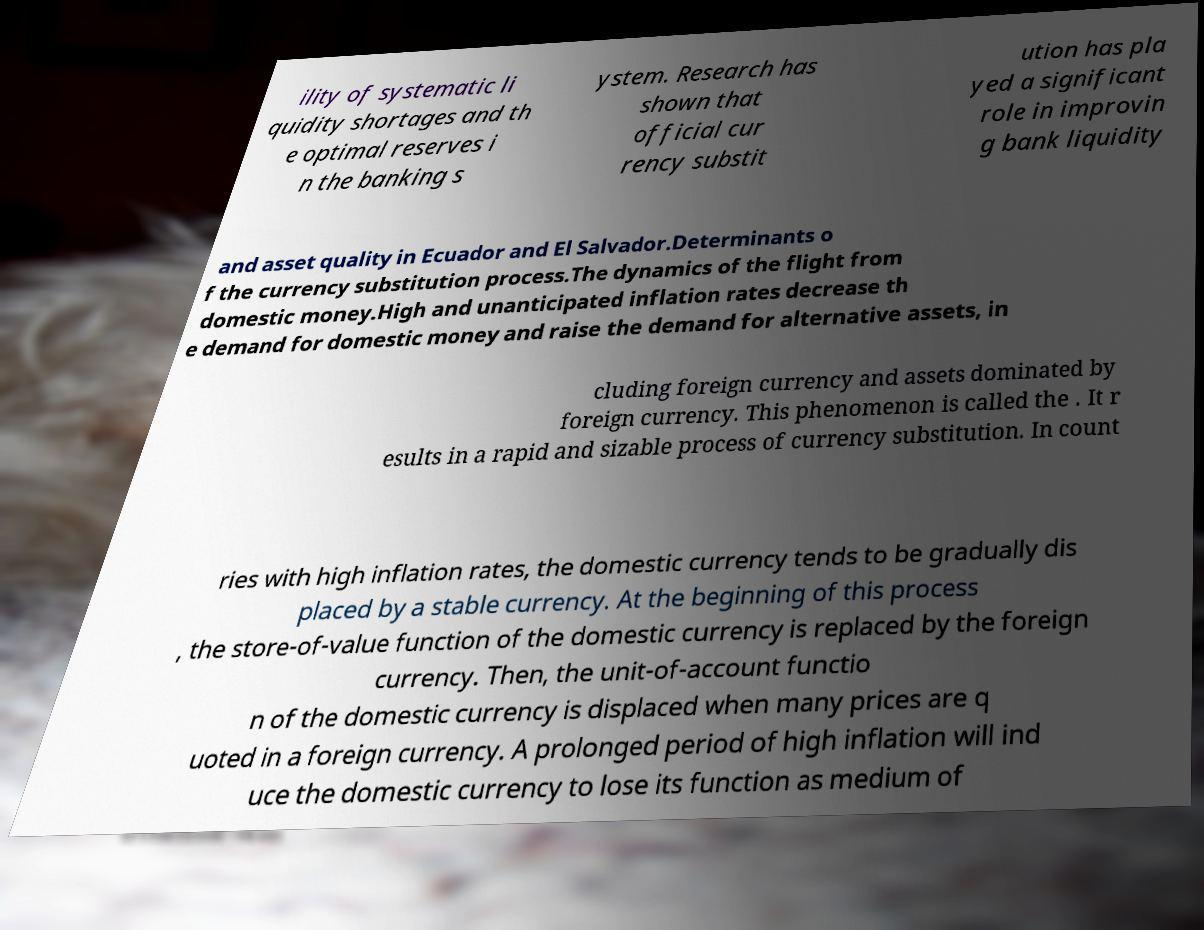What messages or text are displayed in this image? I need them in a readable, typed format. ility of systematic li quidity shortages and th e optimal reserves i n the banking s ystem. Research has shown that official cur rency substit ution has pla yed a significant role in improvin g bank liquidity and asset quality in Ecuador and El Salvador.Determinants o f the currency substitution process.The dynamics of the flight from domestic money.High and unanticipated inflation rates decrease th e demand for domestic money and raise the demand for alternative assets, in cluding foreign currency and assets dominated by foreign currency. This phenomenon is called the . It r esults in a rapid and sizable process of currency substitution. In count ries with high inflation rates, the domestic currency tends to be gradually dis placed by a stable currency. At the beginning of this process , the store-of-value function of the domestic currency is replaced by the foreign currency. Then, the unit-of-account functio n of the domestic currency is displaced when many prices are q uoted in a foreign currency. A prolonged period of high inflation will ind uce the domestic currency to lose its function as medium of 